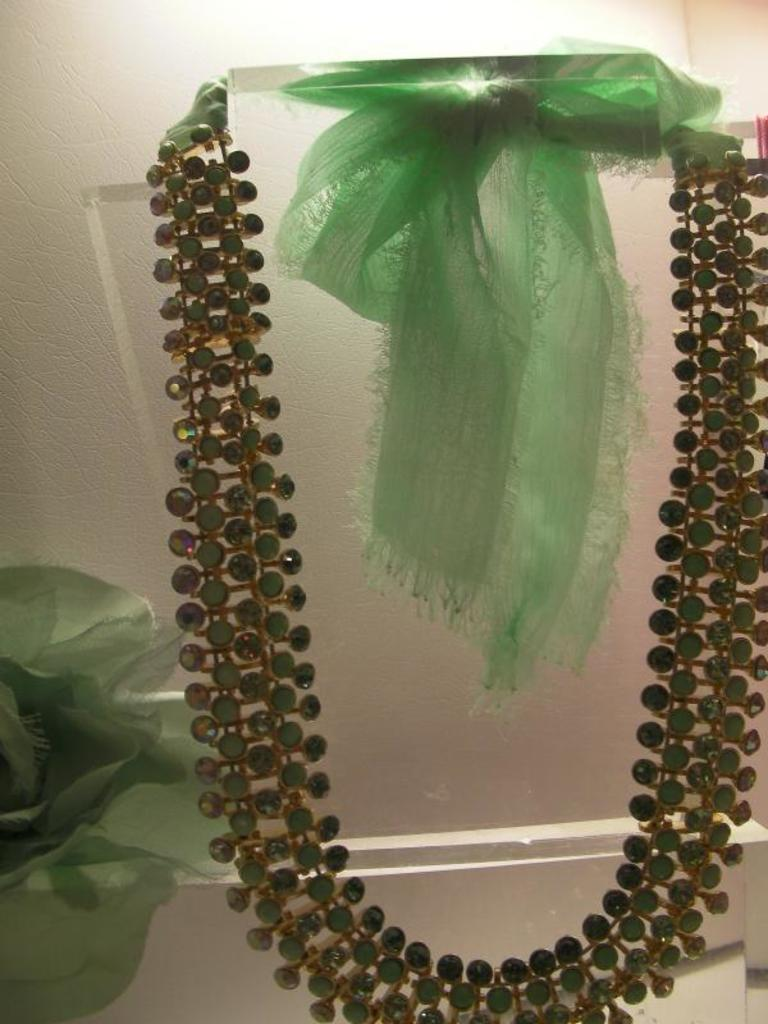What is the main object in the image? There is a chain on a stand in the image. What is attached to the chain? A cloth is tied to the chain. What else can be seen near the stand? There is a cloth at the side of the stand. What can be seen in the background of the image? There is a wall visible in the background of the image. What type of song is being played in the background of the image? There is no song playing in the background of the image; it only features a chain on a stand with a cloth tied to it, another cloth nearby, and a wall in the background. What is the selection of spoons available for use in the image? There is no mention of spoons in the image; it only features a chain on a stand with a cloth tied to it, another cloth nearby, and a wall in the background. 